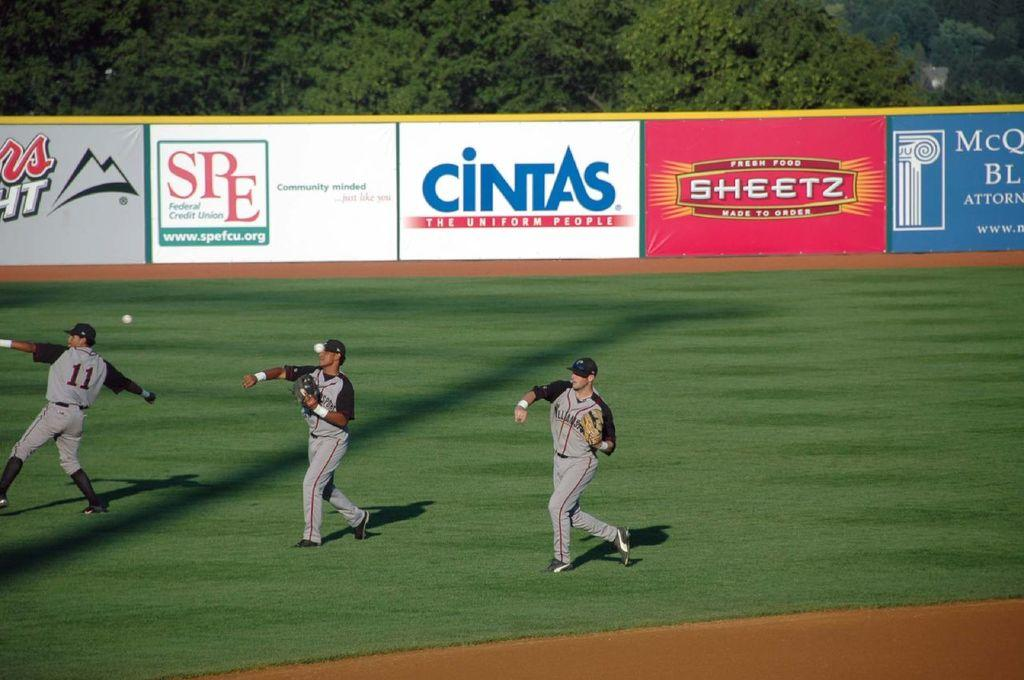<image>
Summarize the visual content of the image. SPE and Cintas put ads around this field 